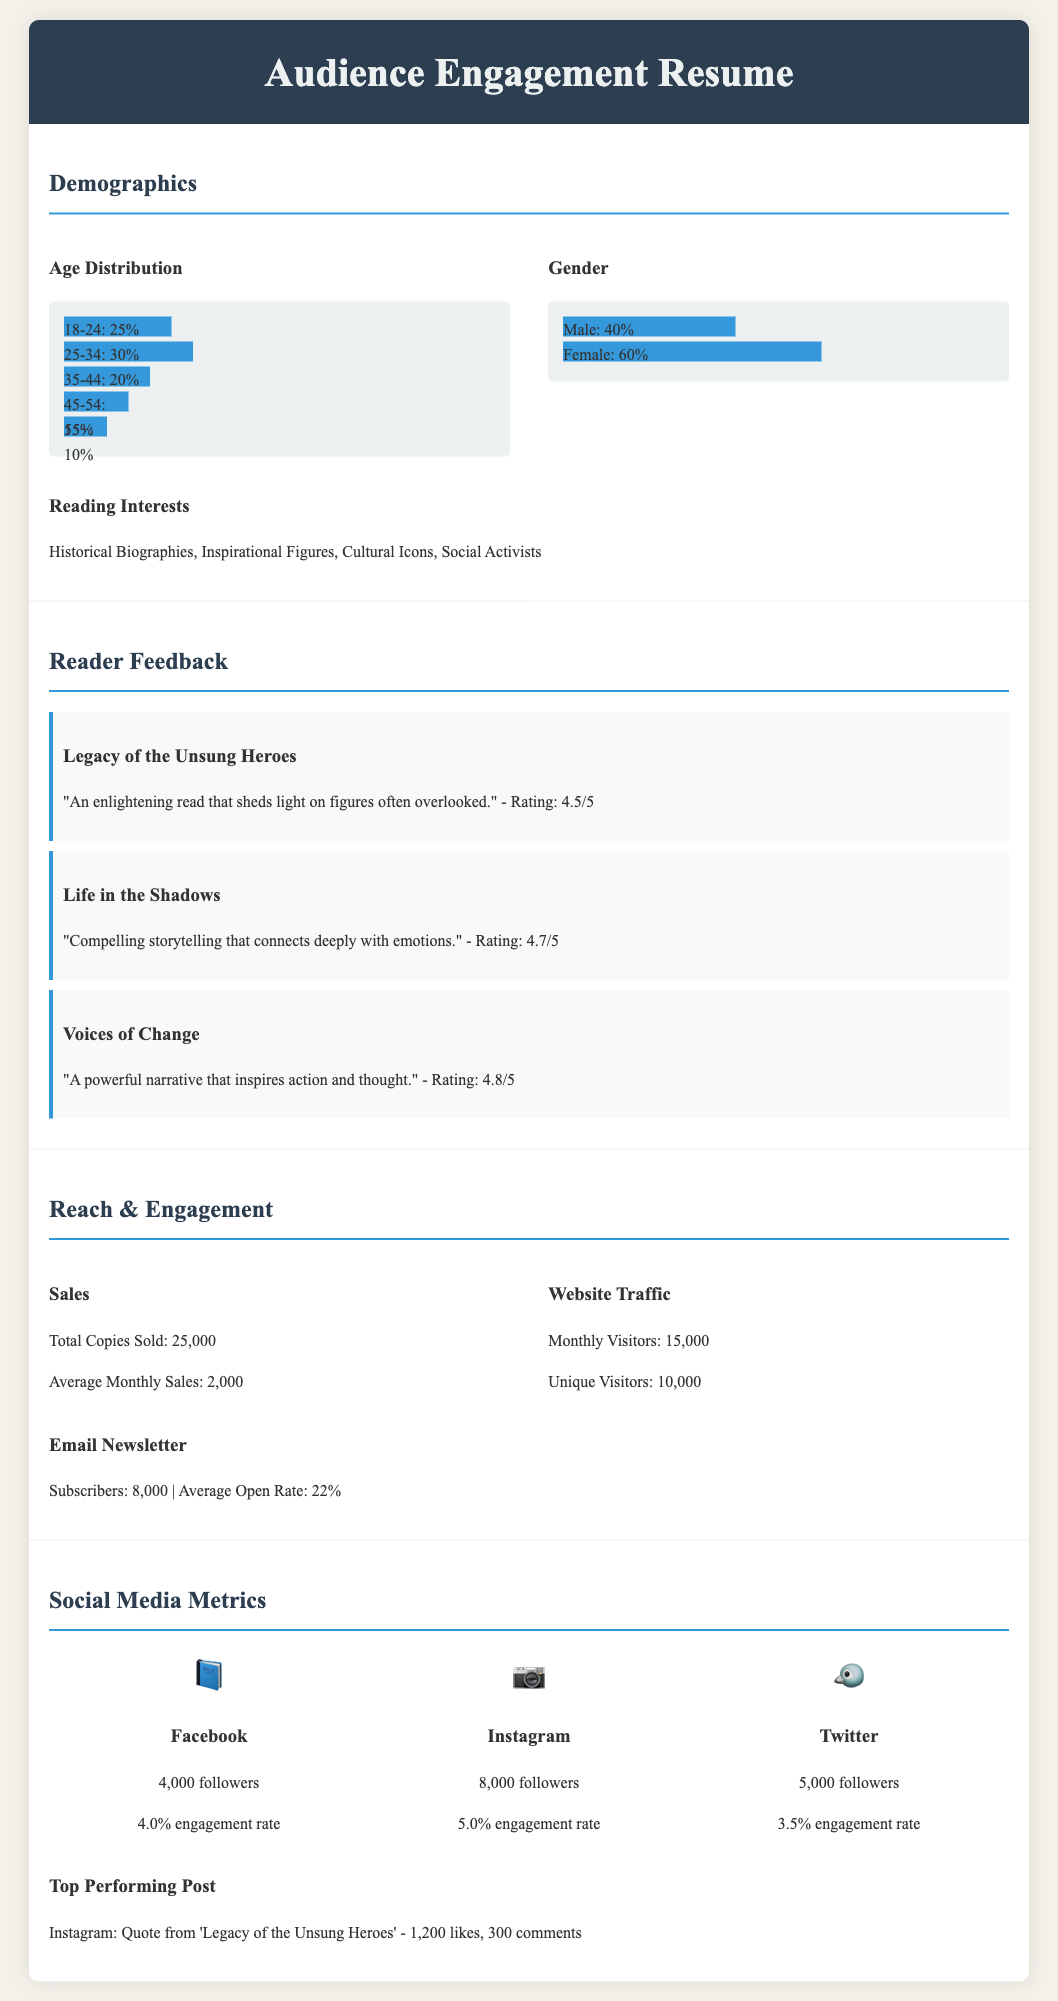What is the age group with the highest percentage? The age group with the highest percentage is 25-34, which accounts for 30%.
Answer: 25-34 What is the female percentage in the demographics? The female percentage represents 60% of the total gender distribution.
Answer: 60% What is the rating for "Voices of Change"? The rating for "Voices of Change" is 4.8 out of 5.
Answer: 4.8/5 How many total copies were sold? The total copies sold is indicated as 25,000 in the document.
Answer: 25,000 What is the average open rate of the email newsletter? The average open rate of the email newsletter is stated as 22%.
Answer: 22% Which social media platform has the highest number of followers? The social media platform with the highest number of followers is Instagram with 8,000 followers.
Answer: Instagram What is the engagement rate for Facebook? The engagement rate for Facebook is reported to be 4.0%.
Answer: 4.0% Which biography received the highest rating? The biography that received the highest rating is "Voices of Change" with a rating of 4.8/5.
Answer: Voices of Change What is the monthly average sales figure? The document states that the average monthly sales figure is 2,000.
Answer: 2,000 